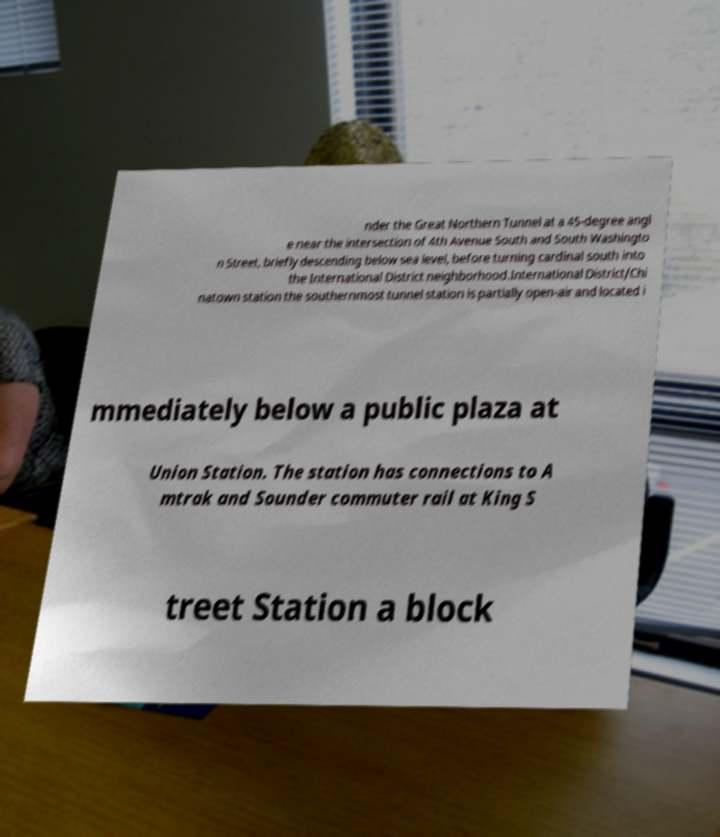There's text embedded in this image that I need extracted. Can you transcribe it verbatim? nder the Great Northern Tunnel at a 45-degree angl e near the intersection of 4th Avenue South and South Washingto n Street, briefly descending below sea level, before turning cardinal south into the International District neighborhood.International District/Chi natown station the southernmost tunnel station is partially open-air and located i mmediately below a public plaza at Union Station. The station has connections to A mtrak and Sounder commuter rail at King S treet Station a block 